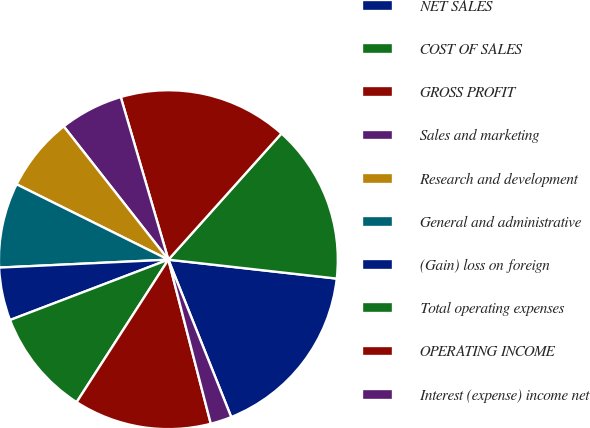<chart> <loc_0><loc_0><loc_500><loc_500><pie_chart><fcel>NET SALES<fcel>COST OF SALES<fcel>GROSS PROFIT<fcel>Sales and marketing<fcel>Research and development<fcel>General and administrative<fcel>(Gain) loss on foreign<fcel>Total operating expenses<fcel>OPERATING INCOME<fcel>Interest (expense) income net<nl><fcel>17.17%<fcel>15.15%<fcel>16.16%<fcel>6.06%<fcel>7.07%<fcel>8.08%<fcel>5.05%<fcel>10.1%<fcel>13.13%<fcel>2.02%<nl></chart> 